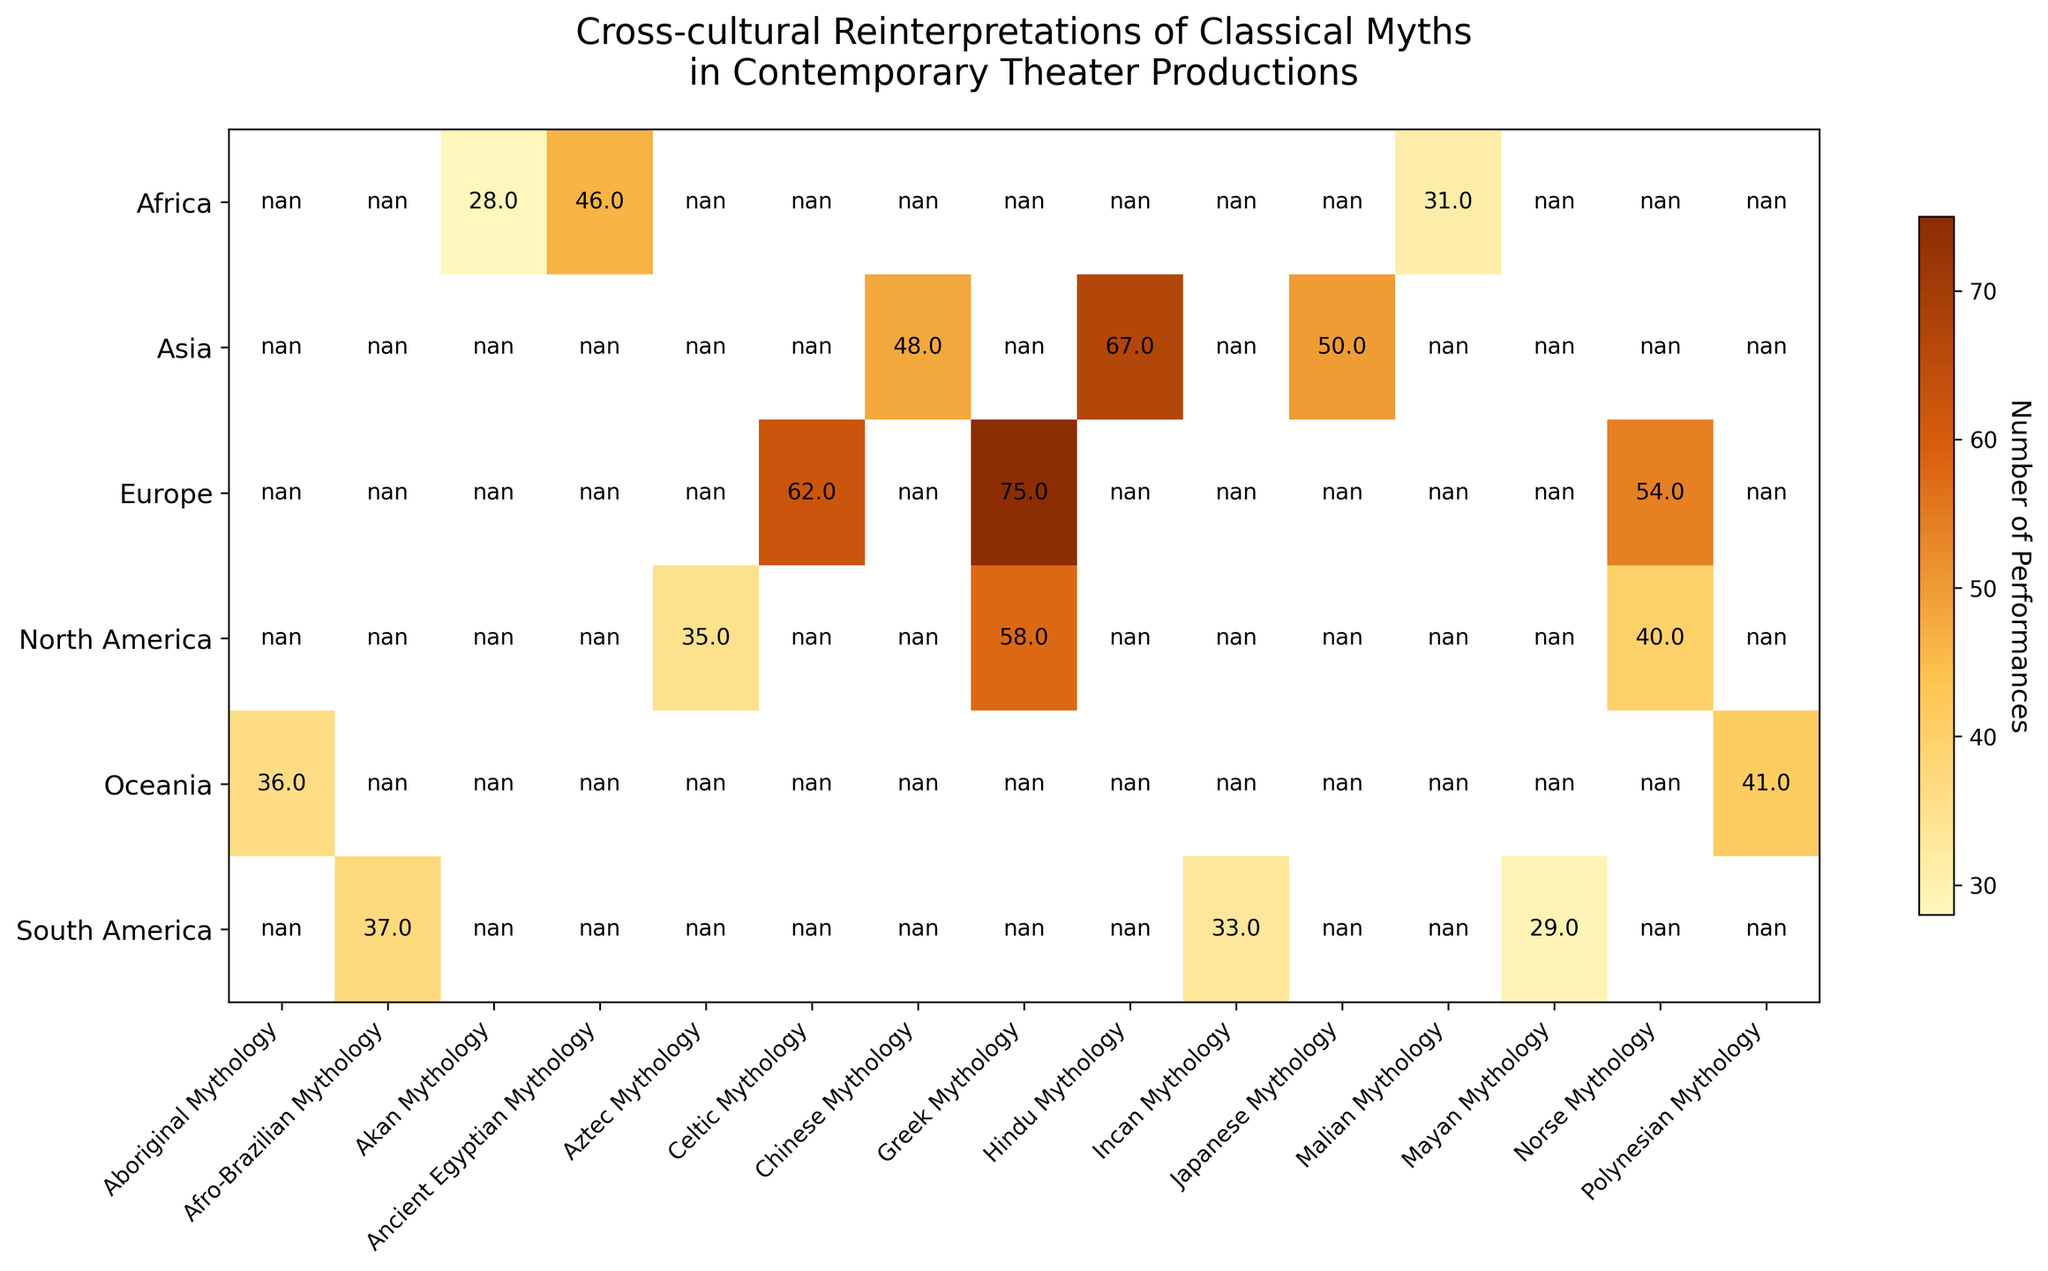Which region has the highest number of performances for Greek Mythology? By observing the figure, you can spot that Europe leads in the number of performances for Greek Mythology. The subplot "Prometheus Reimagined" shows 75 performances in Europe, while North America, represented by "Ariadne Unbound," has 58 performances.
Answer: Europe Which classical myth has the least number of performances in Africa? By checking the different myths and corresponding performance numbers in Africa within the heatmap, "The Wrath of Anansi" (Akan Mythology) has 28 performances, which is the lowest compared to other myths in that region.
Answer: Akan Mythology Which region features the most performances for Norse Mythology? Look for the counts of performances for Norse Mythology in different regions in the heatmap. Europe, with "The Saga of Beowulf," has 54 performances, while North America's "The Spirit of Ragnarok" has only 40.
Answer: Europe What is the total number of performances for classical myths in South America? Sum up the number of performances for all myths in South America. The heatmap shows 33 for Incan, 37 for Afro-Brazilian, and 29 for Mayan Mythology, which totals 33 + 37 + 29 = 99.
Answer: 99 Compare the number of performances of Greek Mythology in North America and Europe. Which one is higher and by how many performances? Europe has 75 performances for Greek Mythology (Prometheus Reimagined) and North America has 58 performances (Ariadne Unbound). Thus, Europe leads by 75 - 58 = 17 performances.
Answer: Europe by 17 Identify the classical mythology with the highest number of performances in Asia. Analyze the heatmap and see that Hindu Mythology representation, "Ramayana Revisited," has the highest number of performances in Asia, exhibiting 67 performances.
Answer: Hindu Mythology Which region has fewer total performances: Oceania or Africa? Calculate the sum for each region. Oceania: Polynesian (41) + Aboriginal (36) = 77. Africa: Akan (28) + Malian (31) + Ancient Egyptian (46) = 105. Comparing these sums, Oceania has fewer performances.
Answer: Oceania What is the average number of performances for classical myths in Europe? Add up the number of performances for each myth in Europe and divide by the number of myths: (75 for Greek + 62 for Celtic + 54 for Norse) / 3 = 191 / 3 = 63.67 (approx).
Answer: 63.67 Which region has the widest range of performance numbers for its myths? Calculate the difference between the maximum and minimum values in each region from the heatmap. Europe: 75 (max) - 54 (min) = 21; North America: 58 - 35 = 23; Asia: 67 - 48 = 19; South America: 37 - 29 = 8; Oceania: 41 - 36 = 5; Africa: 46 - 28 = 18. North America has the widest range (23).
Answer: North America 